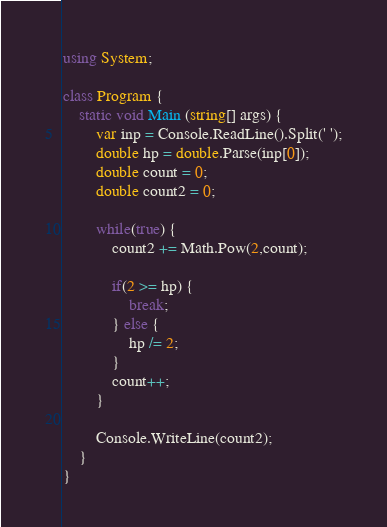Convert code to text. <code><loc_0><loc_0><loc_500><loc_500><_C#_>using System;

class Program {
    static void Main (string[] args) {
        var inp = Console.ReadLine().Split(' ');
        double hp = double.Parse(inp[0]);
        double count = 0;
        double count2 = 0;

        while(true) {
            count2 += Math.Pow(2,count);

            if(2 >= hp) {
                break;
            } else {
                hp /= 2;
            }
            count++;
        }

        Console.WriteLine(count2);
    }
}</code> 